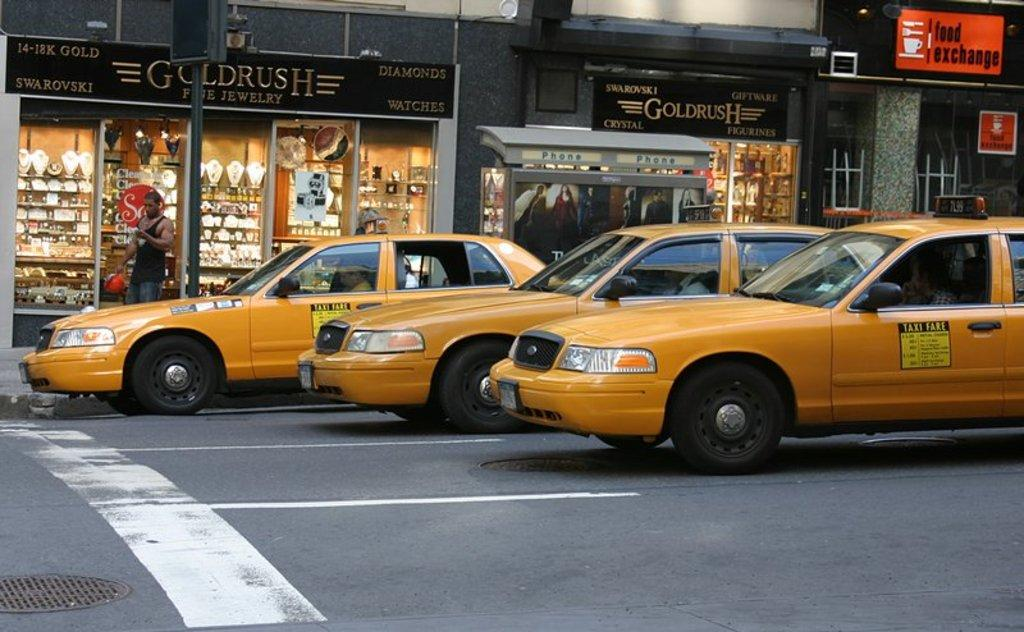<image>
Describe the image concisely. Goldrush Fine Jewelry shop can be seen in the street behind the yellow taxis. 